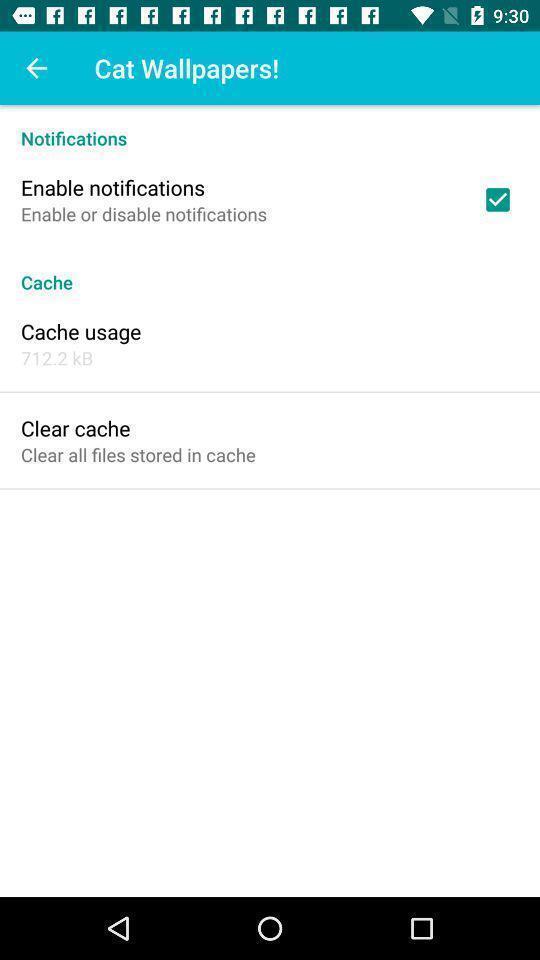What details can you identify in this image? Page showing different options for setting wallpaper. 